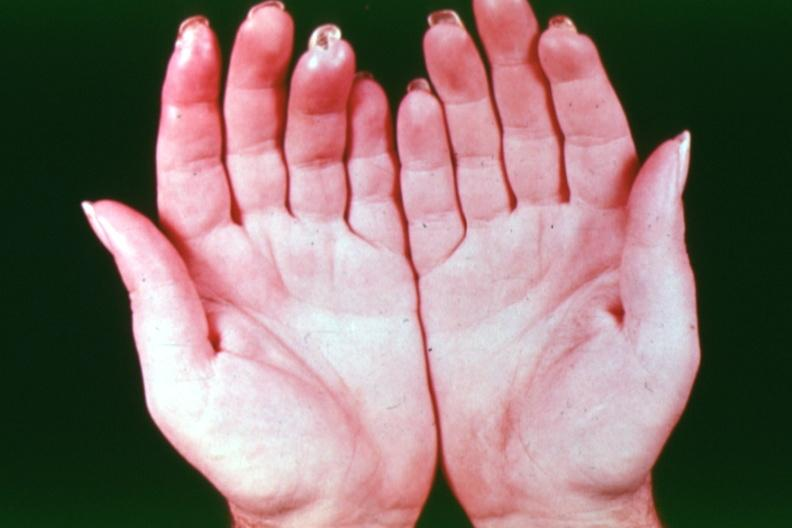does this image show gangrene buergers disease?
Answer the question using a single word or phrase. Yes 